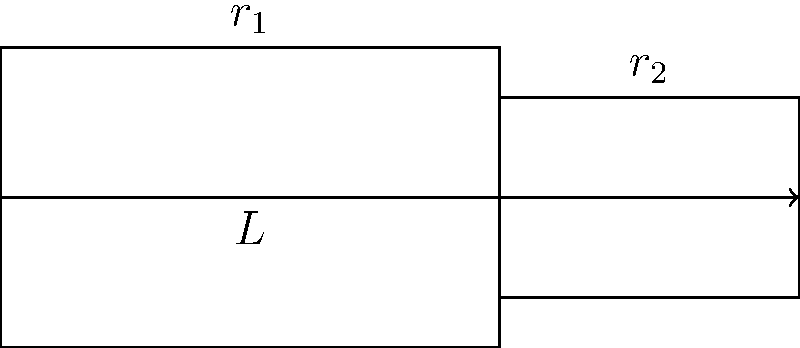Consider blood flow through an artery with a sudden constriction, as shown in the diagram. The artery has an initial radius $r_1 = 2.0$ mm and constricts to a radius $r_2 = 1.5$ mm over a length $L = 5.0$ cm. If the blood flow rate is $Q = 5.0$ mL/s, calculate the change in blood pressure $\Delta P$ across the constriction. Assume blood has a viscosity $\mu = 3.5 \times 10^{-3}$ Pa·s and density $\rho = 1060$ kg/m³. Use the Hagen-Poiseuille equation and the Bernoulli principle to solve this problem. To solve this problem, we'll use a combination of the Hagen-Poiseuille equation and the Bernoulli principle:

1. Calculate velocities:
   $Q = A_1v_1 = A_2v_2$
   $v_1 = \frac{Q}{\pi r_1^2} = \frac{5 \times 10^{-6}}{π (2 \times 10^{-3})^2} = 0.398$ m/s
   $v_2 = \frac{Q}{\pi r_2^2} = \frac{5 \times 10^{-6}}{π (1.5 \times 10^{-3})^2} = 0.707$ m/s

2. Calculate Reynolds numbers:
   $Re_1 = \frac{\rho v_1 d_1}{\mu} = \frac{1060 \times 0.398 \times 0.004}{3.5 \times 10^{-3}} = 480$
   $Re_2 = \frac{\rho v_2 d_2}{\mu} = \frac{1060 \times 0.707 \times 0.003}{3.5 \times 10^{-3}} = 640$
   Both are laminar flow (Re < 2300)

3. Use Hagen-Poiseuille equation for pressure drop in each section:
   $\Delta P_1 = \frac{8\mu LQ}{\pi r_1^4}$ and $\Delta P_2 = \frac{8\mu LQ}{\pi r_2^4}$

4. Use Bernoulli's principle for the sudden constriction:
   $P_1 + \frac{1}{2}\rho v_1^2 = P_2 + \frac{1}{2}\rho v_2^2$
   $\Delta P_{constriction} = P_1 - P_2 = \frac{1}{2}\rho(v_2^2 - v_1^2)$

5. Sum up all pressure changes:
   $\Delta P_{total} = \Delta P_1 + \Delta P_{constriction} + \Delta P_2$

6. Calculate each component:
   $\Delta P_1 = \frac{8 \times 3.5 \times 10^{-3} \times 0.05 \times 5 \times 10^{-6}}{\pi (2 \times 10^{-3})^4} = 69.7$ Pa
   $\Delta P_2 = \frac{8 \times 3.5 \times 10^{-3} \times 0.05 \times 5 \times 10^{-6}}{\pi (1.5 \times 10^{-3})^4} = 220.4$ Pa
   $\Delta P_{constriction} = \frac{1}{2} \times 1060 \times (0.707^2 - 0.398^2) = 186.6$ Pa

7. Sum up the total pressure change:
   $\Delta P_{total} = 69.7 + 186.6 + 220.4 = 476.7$ Pa
Answer: 476.7 Pa 